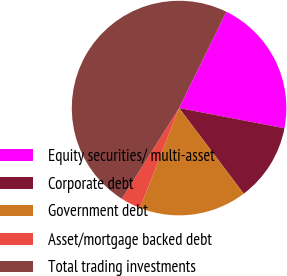<chart> <loc_0><loc_0><loc_500><loc_500><pie_chart><fcel>Equity securities/ multi-asset<fcel>Corporate debt<fcel>Government debt<fcel>Asset/mortgage backed debt<fcel>Total trading investments<nl><fcel>20.75%<fcel>11.69%<fcel>16.22%<fcel>3.02%<fcel>48.31%<nl></chart> 